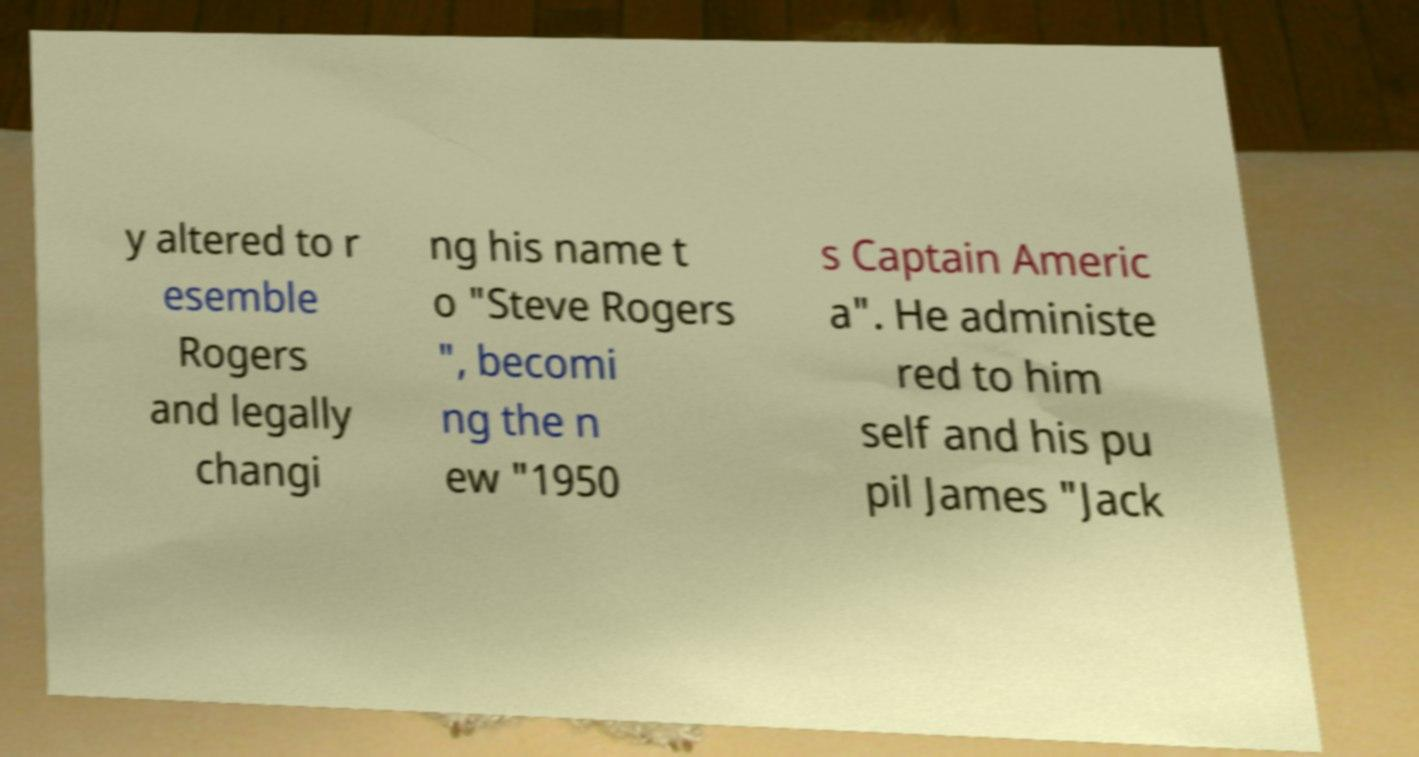For documentation purposes, I need the text within this image transcribed. Could you provide that? y altered to r esemble Rogers and legally changi ng his name t o "Steve Rogers ", becomi ng the n ew "1950 s Captain Americ a". He administe red to him self and his pu pil James "Jack 